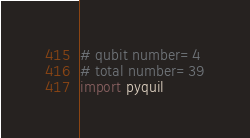<code> <loc_0><loc_0><loc_500><loc_500><_Python_># qubit number=4
# total number=39
import pyquil</code> 